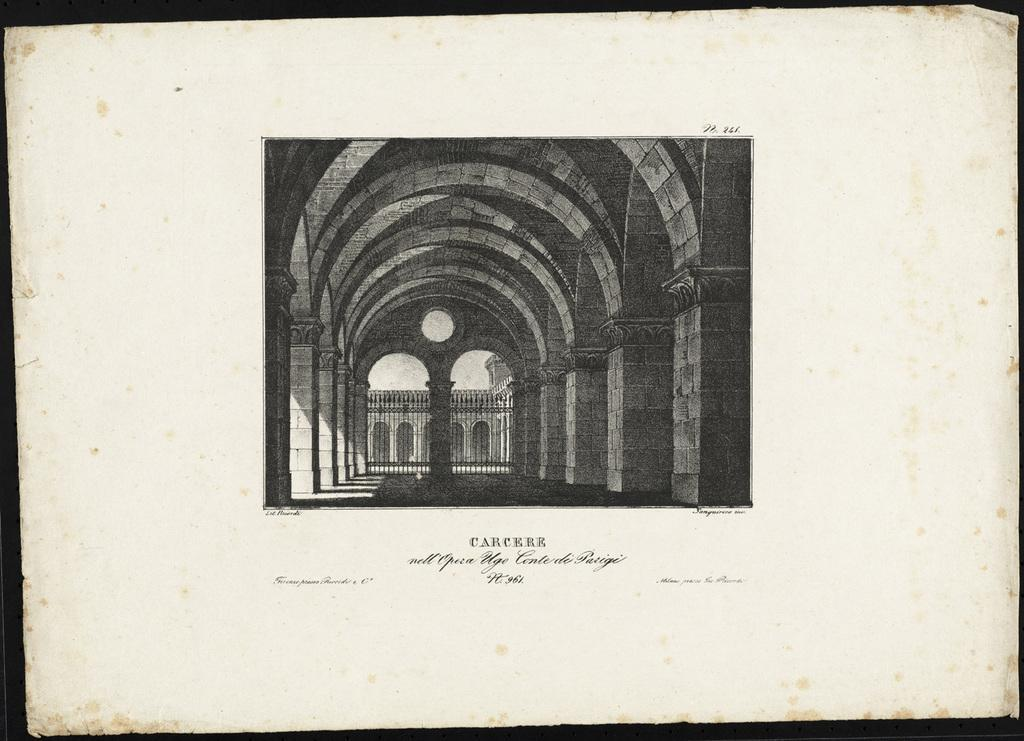What is the main subject of the image? The main subject of the image is a photo of a paper. What can be seen on the paper in the image? The paper contains a picture and some text. What type of thread is used to create the picture on the paper? There is no thread present in the image; the picture on the paper is likely created using a different medium, such as ink or paint. 